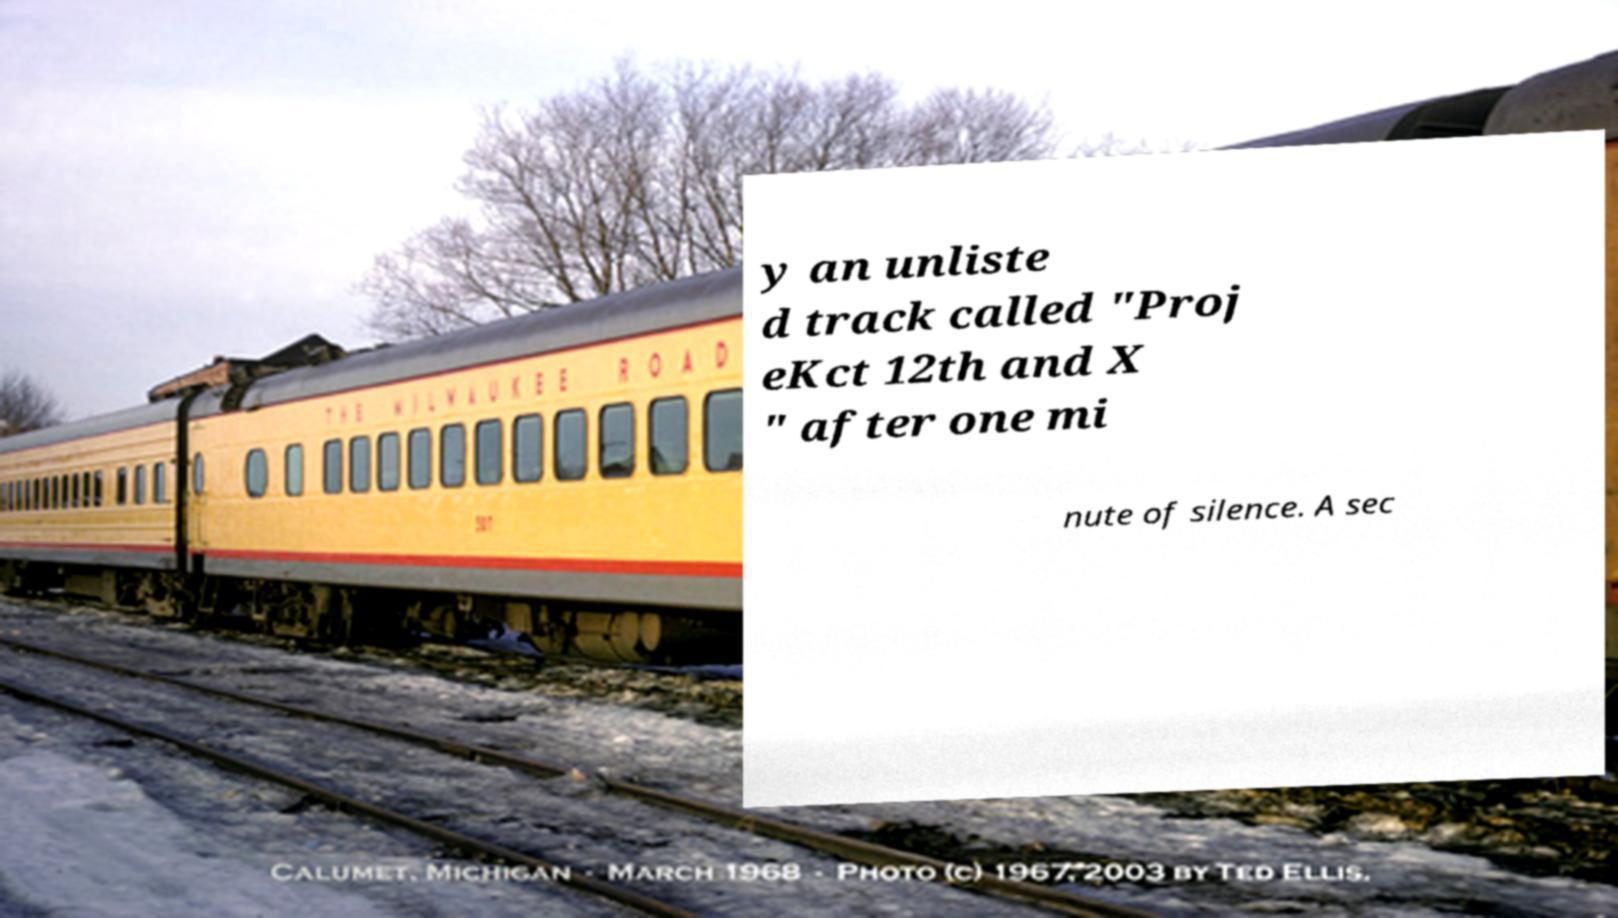What messages or text are displayed in this image? I need them in a readable, typed format. y an unliste d track called "Proj eKct 12th and X " after one mi nute of silence. A sec 